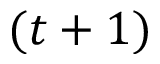Convert formula to latex. <formula><loc_0><loc_0><loc_500><loc_500>( t + 1 )</formula> 